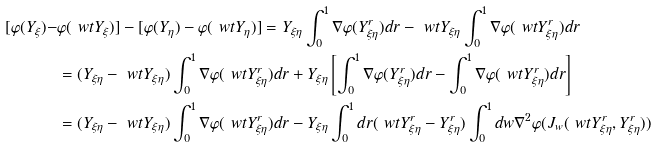Convert formula to latex. <formula><loc_0><loc_0><loc_500><loc_500>[ \varphi ( Y _ { \xi } ) - & \varphi ( \ w t Y _ { \xi } ) ] - [ \varphi ( Y _ { \eta } ) - \varphi ( \ w t Y _ { \eta } ) ] = Y _ { \xi \eta } \int _ { 0 } ^ { 1 } \nabla \varphi ( Y ^ { r } _ { \xi \eta } ) d r - \ w t Y _ { \xi \eta } \int _ { 0 } ^ { 1 } \nabla \varphi ( \ w t Y ^ { r } _ { \xi \eta } ) d r \\ & = ( Y _ { \xi \eta } - \ w t Y _ { \xi \eta } ) \int _ { 0 } ^ { 1 } \nabla \varphi ( \ w t Y ^ { r } _ { \xi \eta } ) d r + Y _ { \xi \eta } \left [ \int _ { 0 } ^ { 1 } \nabla \varphi ( Y ^ { r } _ { \xi \eta } ) d r - \int _ { 0 } ^ { 1 } \nabla \varphi ( \ w t Y ^ { r } _ { \xi \eta } ) d r \right ] \\ & = ( Y _ { \xi \eta } - \ w t Y _ { \xi \eta } ) \int _ { 0 } ^ { 1 } \nabla \varphi ( \ w t Y ^ { r } _ { \xi \eta } ) d r - Y _ { \xi \eta } \int _ { 0 } ^ { 1 } d r ( \ w t Y ^ { r } _ { \xi \eta } - Y ^ { r } _ { \xi \eta } ) \int _ { 0 } ^ { 1 } d w \nabla ^ { 2 } \varphi ( J _ { w } ( \ w t Y ^ { r } _ { \xi \eta } , Y ^ { r } _ { \xi \eta } ) )</formula> 